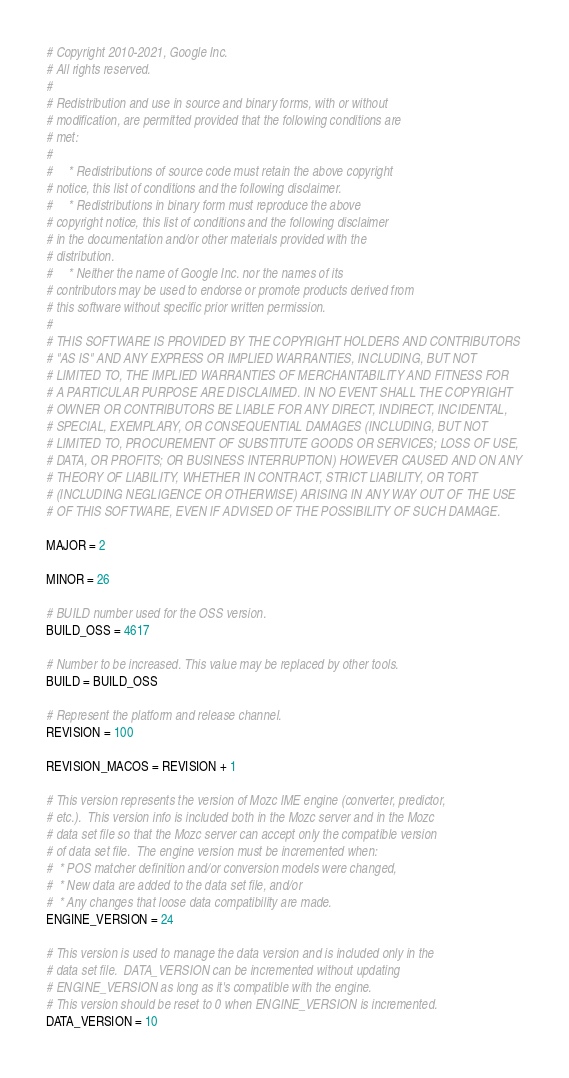Convert code to text. <code><loc_0><loc_0><loc_500><loc_500><_Python_># Copyright 2010-2021, Google Inc.
# All rights reserved.
#
# Redistribution and use in source and binary forms, with or without
# modification, are permitted provided that the following conditions are
# met:
#
#     * Redistributions of source code must retain the above copyright
# notice, this list of conditions and the following disclaimer.
#     * Redistributions in binary form must reproduce the above
# copyright notice, this list of conditions and the following disclaimer
# in the documentation and/or other materials provided with the
# distribution.
#     * Neither the name of Google Inc. nor the names of its
# contributors may be used to endorse or promote products derived from
# this software without specific prior written permission.
#
# THIS SOFTWARE IS PROVIDED BY THE COPYRIGHT HOLDERS AND CONTRIBUTORS
# "AS IS" AND ANY EXPRESS OR IMPLIED WARRANTIES, INCLUDING, BUT NOT
# LIMITED TO, THE IMPLIED WARRANTIES OF MERCHANTABILITY AND FITNESS FOR
# A PARTICULAR PURPOSE ARE DISCLAIMED. IN NO EVENT SHALL THE COPYRIGHT
# OWNER OR CONTRIBUTORS BE LIABLE FOR ANY DIRECT, INDIRECT, INCIDENTAL,
# SPECIAL, EXEMPLARY, OR CONSEQUENTIAL DAMAGES (INCLUDING, BUT NOT
# LIMITED TO, PROCUREMENT OF SUBSTITUTE GOODS OR SERVICES; LOSS OF USE,
# DATA, OR PROFITS; OR BUSINESS INTERRUPTION) HOWEVER CAUSED AND ON ANY
# THEORY OF LIABILITY, WHETHER IN CONTRACT, STRICT LIABILITY, OR TORT
# (INCLUDING NEGLIGENCE OR OTHERWISE) ARISING IN ANY WAY OUT OF THE USE
# OF THIS SOFTWARE, EVEN IF ADVISED OF THE POSSIBILITY OF SUCH DAMAGE.

MAJOR = 2

MINOR = 26

# BUILD number used for the OSS version.
BUILD_OSS = 4617

# Number to be increased. This value may be replaced by other tools.
BUILD = BUILD_OSS

# Represent the platform and release channel.
REVISION = 100

REVISION_MACOS = REVISION + 1

# This version represents the version of Mozc IME engine (converter, predictor,
# etc.).  This version info is included both in the Mozc server and in the Mozc
# data set file so that the Mozc server can accept only the compatible version
# of data set file.  The engine version must be incremented when:
#  * POS matcher definition and/or conversion models were changed,
#  * New data are added to the data set file, and/or
#  * Any changes that loose data compatibility are made.
ENGINE_VERSION = 24

# This version is used to manage the data version and is included only in the
# data set file.  DATA_VERSION can be incremented without updating
# ENGINE_VERSION as long as it's compatible with the engine.
# This version should be reset to 0 when ENGINE_VERSION is incremented.
DATA_VERSION = 10
</code> 